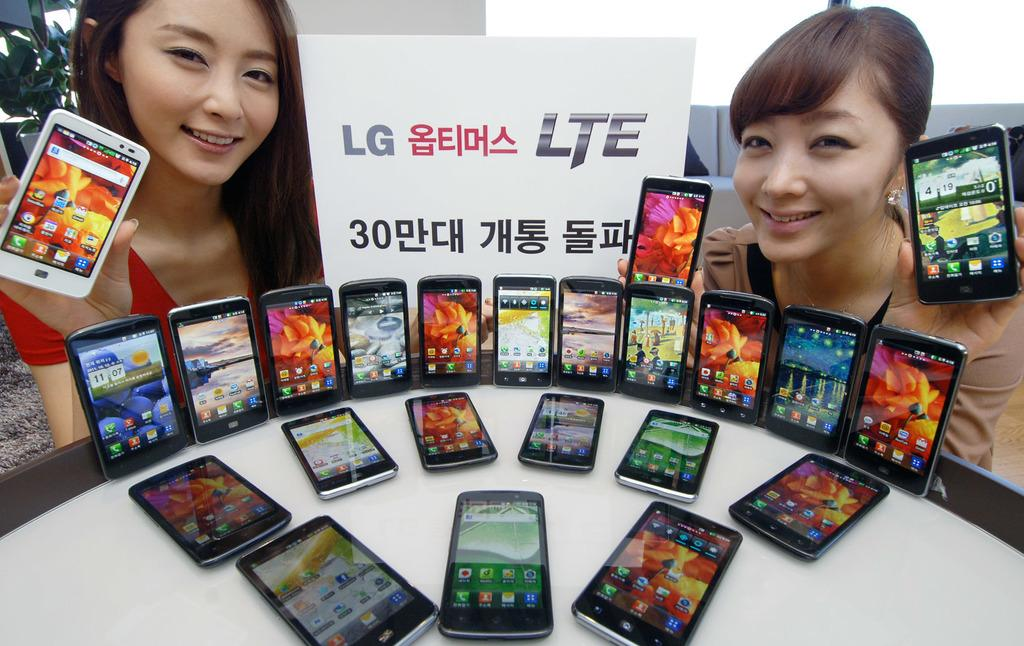<image>
Render a clear and concise summary of the photo. a phone that has the number 419 on it 